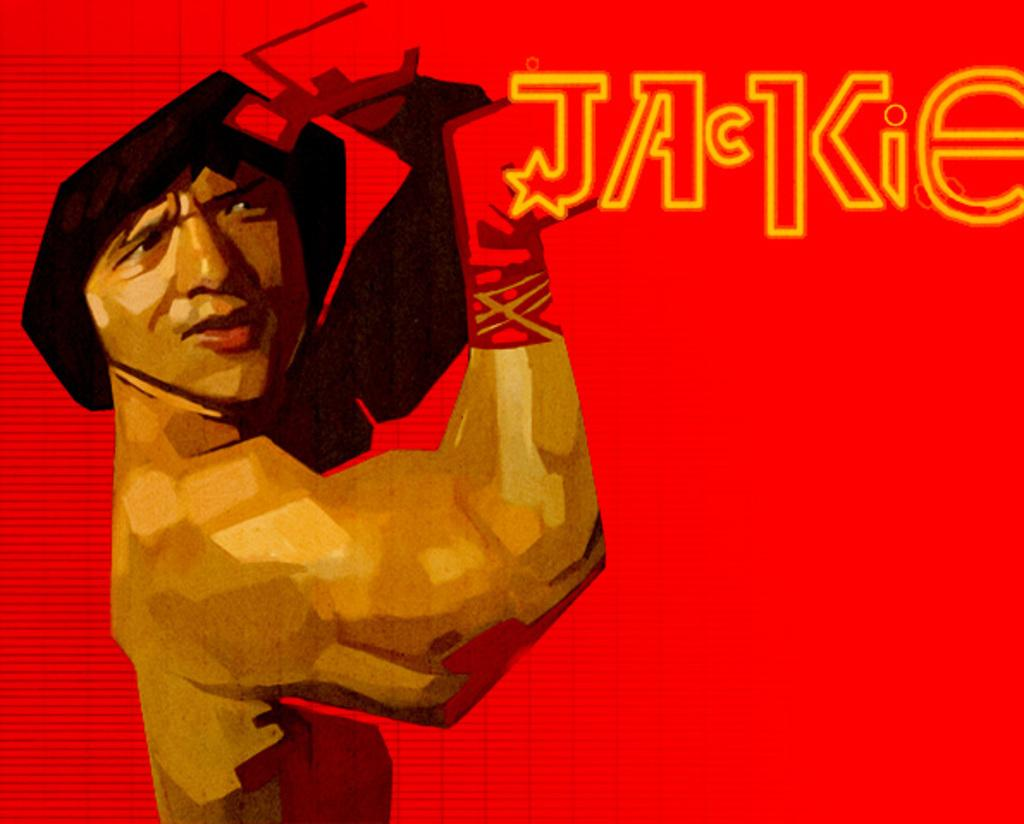Who is on the left side of the image? There is a man on the left side of the image. What can be seen at the top of the image? There is text at the top of the image. What type of insect can be seen flying in the rainstorm in the image? There is no insect or rainstorm present in the image; it only features a man and text. 